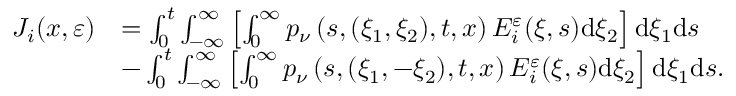<formula> <loc_0><loc_0><loc_500><loc_500>\begin{array} { r l } { J _ { i } ( x , \varepsilon ) } & { = \int _ { 0 } ^ { t } \int _ { - \infty } ^ { \infty } \left [ \int _ { 0 } ^ { \infty } p _ { \nu } \left ( s , ( \xi _ { 1 } , \xi _ { 2 } ) , t , x \right ) E _ { i } ^ { \varepsilon } ( \xi , s ) d \xi _ { 2 } \right ] d \xi _ { 1 } d s } \\ & { - \int _ { 0 } ^ { t } \int _ { - \infty } ^ { \infty } \left [ \int _ { 0 } ^ { \infty } p _ { \nu } \left ( s , ( \xi _ { 1 } , - \xi _ { 2 } ) , t , x \right ) E _ { i } ^ { \varepsilon } ( \xi , s ) d \xi _ { 2 } \right ] d \xi _ { 1 } d s . } \end{array}</formula> 